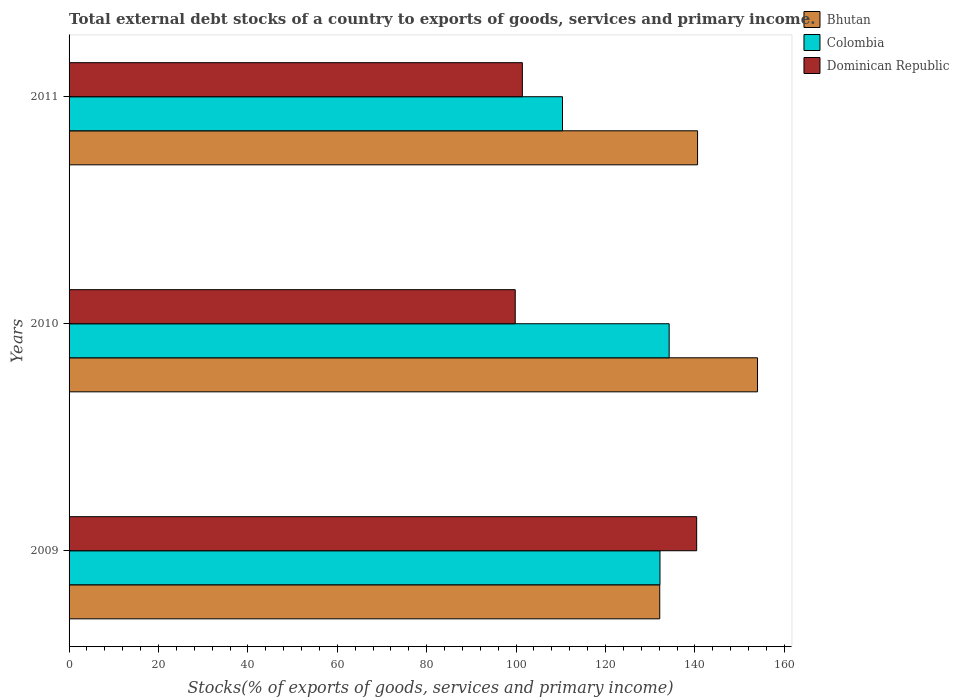How many groups of bars are there?
Provide a short and direct response. 3. Are the number of bars per tick equal to the number of legend labels?
Your answer should be compact. Yes. Are the number of bars on each tick of the Y-axis equal?
Offer a very short reply. Yes. How many bars are there on the 3rd tick from the top?
Your answer should be compact. 3. In how many cases, is the number of bars for a given year not equal to the number of legend labels?
Give a very brief answer. 0. What is the total debt stocks in Bhutan in 2009?
Offer a terse response. 132.13. Across all years, what is the maximum total debt stocks in Bhutan?
Your answer should be very brief. 154.01. Across all years, what is the minimum total debt stocks in Bhutan?
Give a very brief answer. 132.13. In which year was the total debt stocks in Dominican Republic maximum?
Provide a short and direct response. 2009. What is the total total debt stocks in Colombia in the graph?
Your answer should be very brief. 376.8. What is the difference between the total debt stocks in Bhutan in 2009 and that in 2011?
Give a very brief answer. -8.46. What is the difference between the total debt stocks in Bhutan in 2009 and the total debt stocks in Colombia in 2011?
Offer a very short reply. 21.75. What is the average total debt stocks in Colombia per year?
Provide a short and direct response. 125.6. In the year 2011, what is the difference between the total debt stocks in Dominican Republic and total debt stocks in Bhutan?
Ensure brevity in your answer.  -39.19. In how many years, is the total debt stocks in Bhutan greater than 4 %?
Your response must be concise. 3. What is the ratio of the total debt stocks in Colombia in 2009 to that in 2011?
Keep it short and to the point. 1.2. Is the difference between the total debt stocks in Dominican Republic in 2009 and 2010 greater than the difference between the total debt stocks in Bhutan in 2009 and 2010?
Offer a terse response. Yes. What is the difference between the highest and the second highest total debt stocks in Colombia?
Your answer should be very brief. 2.05. What is the difference between the highest and the lowest total debt stocks in Dominican Republic?
Keep it short and to the point. 40.59. Is the sum of the total debt stocks in Colombia in 2009 and 2010 greater than the maximum total debt stocks in Bhutan across all years?
Make the answer very short. Yes. What does the 3rd bar from the bottom in 2011 represents?
Ensure brevity in your answer.  Dominican Republic. Is it the case that in every year, the sum of the total debt stocks in Bhutan and total debt stocks in Colombia is greater than the total debt stocks in Dominican Republic?
Your response must be concise. Yes. How many bars are there?
Make the answer very short. 9. Are all the bars in the graph horizontal?
Keep it short and to the point. Yes. How many years are there in the graph?
Keep it short and to the point. 3. What is the difference between two consecutive major ticks on the X-axis?
Give a very brief answer. 20. Does the graph contain grids?
Your answer should be very brief. No. How many legend labels are there?
Provide a short and direct response. 3. What is the title of the graph?
Offer a very short reply. Total external debt stocks of a country to exports of goods, services and primary income. Does "Morocco" appear as one of the legend labels in the graph?
Make the answer very short. No. What is the label or title of the X-axis?
Make the answer very short. Stocks(% of exports of goods, services and primary income). What is the Stocks(% of exports of goods, services and primary income) in Bhutan in 2009?
Give a very brief answer. 132.13. What is the Stocks(% of exports of goods, services and primary income) in Colombia in 2009?
Give a very brief answer. 132.18. What is the Stocks(% of exports of goods, services and primary income) of Dominican Republic in 2009?
Provide a succinct answer. 140.39. What is the Stocks(% of exports of goods, services and primary income) of Bhutan in 2010?
Your answer should be compact. 154.01. What is the Stocks(% of exports of goods, services and primary income) in Colombia in 2010?
Offer a very short reply. 134.24. What is the Stocks(% of exports of goods, services and primary income) of Dominican Republic in 2010?
Your response must be concise. 99.8. What is the Stocks(% of exports of goods, services and primary income) in Bhutan in 2011?
Offer a terse response. 140.59. What is the Stocks(% of exports of goods, services and primary income) of Colombia in 2011?
Provide a short and direct response. 110.38. What is the Stocks(% of exports of goods, services and primary income) of Dominican Republic in 2011?
Offer a terse response. 101.4. Across all years, what is the maximum Stocks(% of exports of goods, services and primary income) in Bhutan?
Your answer should be very brief. 154.01. Across all years, what is the maximum Stocks(% of exports of goods, services and primary income) in Colombia?
Provide a succinct answer. 134.24. Across all years, what is the maximum Stocks(% of exports of goods, services and primary income) in Dominican Republic?
Your answer should be compact. 140.39. Across all years, what is the minimum Stocks(% of exports of goods, services and primary income) in Bhutan?
Give a very brief answer. 132.13. Across all years, what is the minimum Stocks(% of exports of goods, services and primary income) in Colombia?
Provide a succinct answer. 110.38. Across all years, what is the minimum Stocks(% of exports of goods, services and primary income) of Dominican Republic?
Keep it short and to the point. 99.8. What is the total Stocks(% of exports of goods, services and primary income) in Bhutan in the graph?
Provide a short and direct response. 426.73. What is the total Stocks(% of exports of goods, services and primary income) in Colombia in the graph?
Offer a terse response. 376.8. What is the total Stocks(% of exports of goods, services and primary income) in Dominican Republic in the graph?
Give a very brief answer. 341.59. What is the difference between the Stocks(% of exports of goods, services and primary income) in Bhutan in 2009 and that in 2010?
Your answer should be compact. -21.87. What is the difference between the Stocks(% of exports of goods, services and primary income) of Colombia in 2009 and that in 2010?
Give a very brief answer. -2.05. What is the difference between the Stocks(% of exports of goods, services and primary income) of Dominican Republic in 2009 and that in 2010?
Make the answer very short. 40.59. What is the difference between the Stocks(% of exports of goods, services and primary income) of Bhutan in 2009 and that in 2011?
Give a very brief answer. -8.46. What is the difference between the Stocks(% of exports of goods, services and primary income) in Colombia in 2009 and that in 2011?
Keep it short and to the point. 21.81. What is the difference between the Stocks(% of exports of goods, services and primary income) of Dominican Republic in 2009 and that in 2011?
Your answer should be very brief. 38.99. What is the difference between the Stocks(% of exports of goods, services and primary income) in Bhutan in 2010 and that in 2011?
Your response must be concise. 13.42. What is the difference between the Stocks(% of exports of goods, services and primary income) of Colombia in 2010 and that in 2011?
Make the answer very short. 23.86. What is the difference between the Stocks(% of exports of goods, services and primary income) of Dominican Republic in 2010 and that in 2011?
Your answer should be very brief. -1.6. What is the difference between the Stocks(% of exports of goods, services and primary income) in Bhutan in 2009 and the Stocks(% of exports of goods, services and primary income) in Colombia in 2010?
Your answer should be very brief. -2.1. What is the difference between the Stocks(% of exports of goods, services and primary income) of Bhutan in 2009 and the Stocks(% of exports of goods, services and primary income) of Dominican Republic in 2010?
Your answer should be compact. 32.33. What is the difference between the Stocks(% of exports of goods, services and primary income) of Colombia in 2009 and the Stocks(% of exports of goods, services and primary income) of Dominican Republic in 2010?
Your answer should be very brief. 32.38. What is the difference between the Stocks(% of exports of goods, services and primary income) in Bhutan in 2009 and the Stocks(% of exports of goods, services and primary income) in Colombia in 2011?
Ensure brevity in your answer.  21.75. What is the difference between the Stocks(% of exports of goods, services and primary income) of Bhutan in 2009 and the Stocks(% of exports of goods, services and primary income) of Dominican Republic in 2011?
Provide a short and direct response. 30.73. What is the difference between the Stocks(% of exports of goods, services and primary income) of Colombia in 2009 and the Stocks(% of exports of goods, services and primary income) of Dominican Republic in 2011?
Give a very brief answer. 30.78. What is the difference between the Stocks(% of exports of goods, services and primary income) of Bhutan in 2010 and the Stocks(% of exports of goods, services and primary income) of Colombia in 2011?
Make the answer very short. 43.63. What is the difference between the Stocks(% of exports of goods, services and primary income) in Bhutan in 2010 and the Stocks(% of exports of goods, services and primary income) in Dominican Republic in 2011?
Keep it short and to the point. 52.61. What is the difference between the Stocks(% of exports of goods, services and primary income) in Colombia in 2010 and the Stocks(% of exports of goods, services and primary income) in Dominican Republic in 2011?
Keep it short and to the point. 32.84. What is the average Stocks(% of exports of goods, services and primary income) of Bhutan per year?
Keep it short and to the point. 142.24. What is the average Stocks(% of exports of goods, services and primary income) of Colombia per year?
Offer a very short reply. 125.6. What is the average Stocks(% of exports of goods, services and primary income) in Dominican Republic per year?
Your answer should be compact. 113.86. In the year 2009, what is the difference between the Stocks(% of exports of goods, services and primary income) in Bhutan and Stocks(% of exports of goods, services and primary income) in Colombia?
Your answer should be compact. -0.05. In the year 2009, what is the difference between the Stocks(% of exports of goods, services and primary income) in Bhutan and Stocks(% of exports of goods, services and primary income) in Dominican Republic?
Offer a very short reply. -8.26. In the year 2009, what is the difference between the Stocks(% of exports of goods, services and primary income) in Colombia and Stocks(% of exports of goods, services and primary income) in Dominican Republic?
Give a very brief answer. -8.21. In the year 2010, what is the difference between the Stocks(% of exports of goods, services and primary income) in Bhutan and Stocks(% of exports of goods, services and primary income) in Colombia?
Your answer should be very brief. 19.77. In the year 2010, what is the difference between the Stocks(% of exports of goods, services and primary income) in Bhutan and Stocks(% of exports of goods, services and primary income) in Dominican Republic?
Make the answer very short. 54.2. In the year 2010, what is the difference between the Stocks(% of exports of goods, services and primary income) of Colombia and Stocks(% of exports of goods, services and primary income) of Dominican Republic?
Keep it short and to the point. 34.43. In the year 2011, what is the difference between the Stocks(% of exports of goods, services and primary income) of Bhutan and Stocks(% of exports of goods, services and primary income) of Colombia?
Keep it short and to the point. 30.21. In the year 2011, what is the difference between the Stocks(% of exports of goods, services and primary income) in Bhutan and Stocks(% of exports of goods, services and primary income) in Dominican Republic?
Your answer should be compact. 39.19. In the year 2011, what is the difference between the Stocks(% of exports of goods, services and primary income) of Colombia and Stocks(% of exports of goods, services and primary income) of Dominican Republic?
Your answer should be compact. 8.98. What is the ratio of the Stocks(% of exports of goods, services and primary income) in Bhutan in 2009 to that in 2010?
Offer a very short reply. 0.86. What is the ratio of the Stocks(% of exports of goods, services and primary income) of Colombia in 2009 to that in 2010?
Offer a terse response. 0.98. What is the ratio of the Stocks(% of exports of goods, services and primary income) of Dominican Republic in 2009 to that in 2010?
Your response must be concise. 1.41. What is the ratio of the Stocks(% of exports of goods, services and primary income) in Bhutan in 2009 to that in 2011?
Provide a short and direct response. 0.94. What is the ratio of the Stocks(% of exports of goods, services and primary income) of Colombia in 2009 to that in 2011?
Give a very brief answer. 1.2. What is the ratio of the Stocks(% of exports of goods, services and primary income) in Dominican Republic in 2009 to that in 2011?
Offer a very short reply. 1.38. What is the ratio of the Stocks(% of exports of goods, services and primary income) of Bhutan in 2010 to that in 2011?
Provide a short and direct response. 1.1. What is the ratio of the Stocks(% of exports of goods, services and primary income) in Colombia in 2010 to that in 2011?
Provide a short and direct response. 1.22. What is the ratio of the Stocks(% of exports of goods, services and primary income) of Dominican Republic in 2010 to that in 2011?
Provide a succinct answer. 0.98. What is the difference between the highest and the second highest Stocks(% of exports of goods, services and primary income) of Bhutan?
Make the answer very short. 13.42. What is the difference between the highest and the second highest Stocks(% of exports of goods, services and primary income) in Colombia?
Give a very brief answer. 2.05. What is the difference between the highest and the second highest Stocks(% of exports of goods, services and primary income) of Dominican Republic?
Your response must be concise. 38.99. What is the difference between the highest and the lowest Stocks(% of exports of goods, services and primary income) of Bhutan?
Your answer should be compact. 21.87. What is the difference between the highest and the lowest Stocks(% of exports of goods, services and primary income) of Colombia?
Provide a succinct answer. 23.86. What is the difference between the highest and the lowest Stocks(% of exports of goods, services and primary income) in Dominican Republic?
Provide a succinct answer. 40.59. 